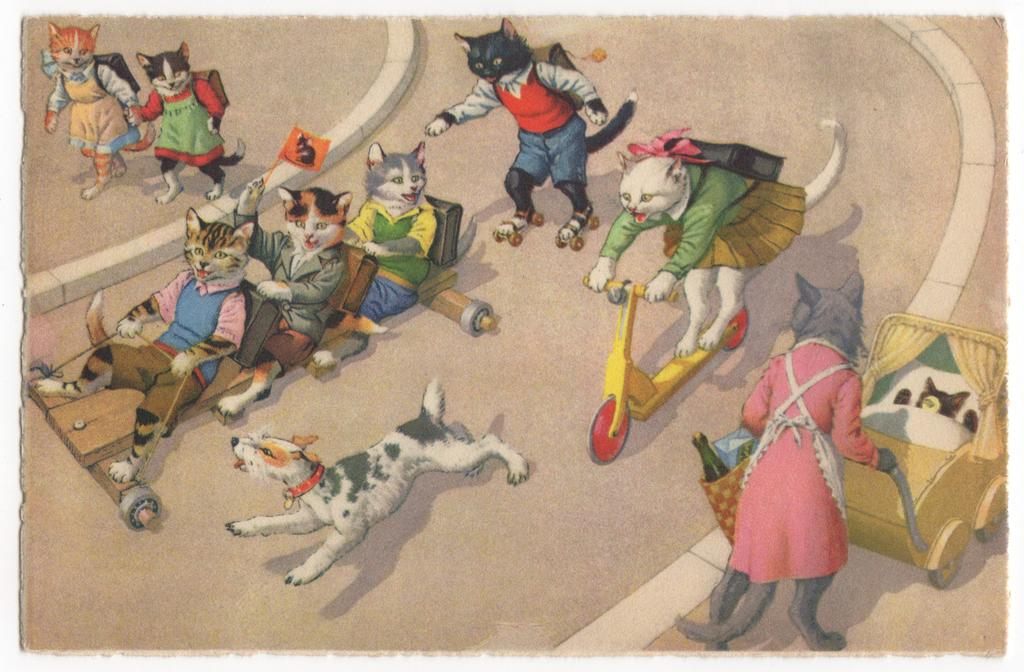What type of animals are present in the image? There are cats and a dog in the image. Are the cats in the image still or moving? The cats in the image are animated, which suggests they are moving. What type of house is visible in the image? There is no house present in the image; it features animated cats and a dog. What tooth-related item can be seen in the image? There is no tooth-related item present in the image. 